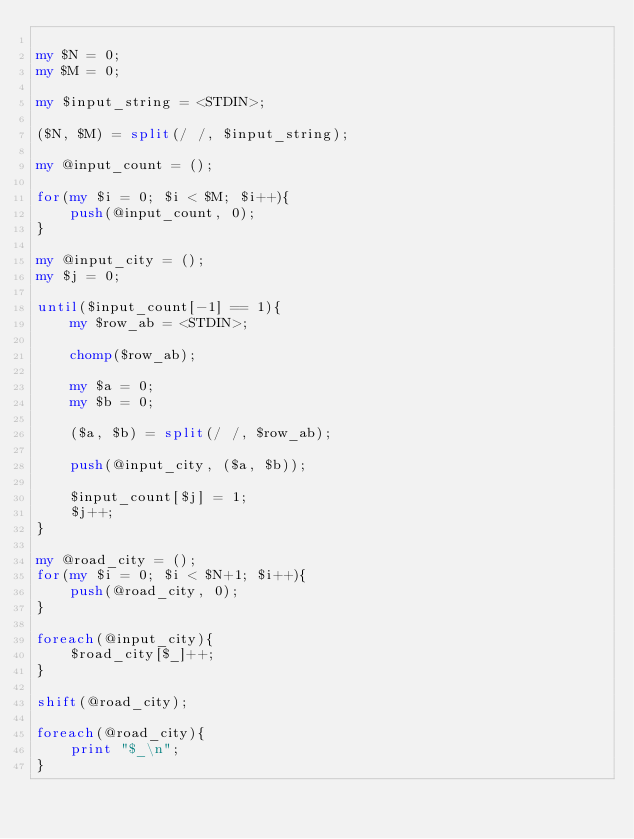<code> <loc_0><loc_0><loc_500><loc_500><_Perl_>
my $N = 0;
my $M = 0;

my $input_string = <STDIN>;

($N, $M) = split(/ /, $input_string);

my @input_count = ();

for(my $i = 0; $i < $M; $i++){
	push(@input_count, 0);
}

my @input_city = ();
my $j = 0;

until($input_count[-1] == 1){
	my $row_ab = <STDIN>;

	chomp($row_ab);

	my $a = 0;
	my $b = 0;

	($a, $b) = split(/ /, $row_ab);
	
	push(@input_city, ($a, $b));
	
	$input_count[$j] = 1;
	$j++;
}

my @road_city = ();
for(my $i = 0; $i < $N+1; $i++){
	push(@road_city, 0);
}

foreach(@input_city){
	$road_city[$_]++;
}

shift(@road_city);

foreach(@road_city){
	print "$_\n";
}</code> 